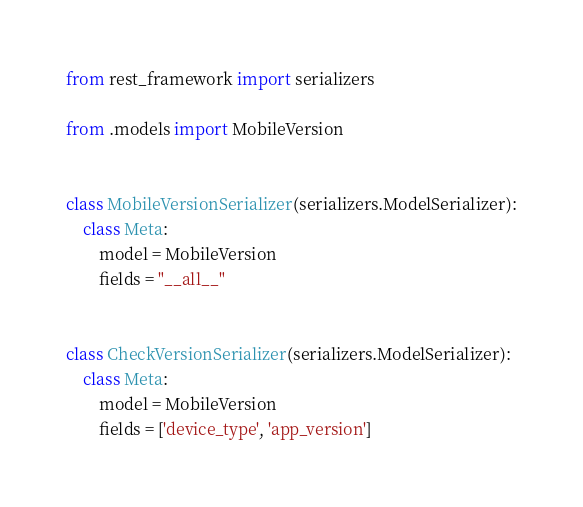Convert code to text. <code><loc_0><loc_0><loc_500><loc_500><_Python_>from rest_framework import serializers

from .models import MobileVersion


class MobileVersionSerializer(serializers.ModelSerializer):
    class Meta:
        model = MobileVersion
        fields = "__all__"


class CheckVersionSerializer(serializers.ModelSerializer):
    class Meta:
        model = MobileVersion
        fields = ['device_type', 'app_version']
</code> 